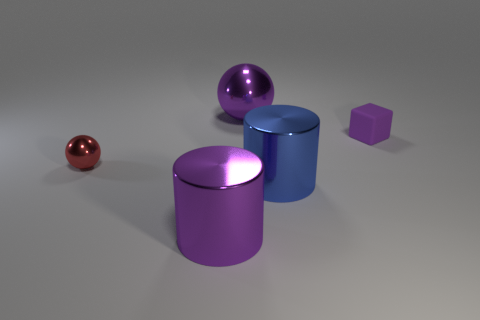How many green things are balls or big metallic things?
Provide a succinct answer. 0. The large metallic sphere has what color?
Offer a terse response. Purple. Are there any other things that are made of the same material as the purple cube?
Provide a short and direct response. No. Are there fewer big purple metallic spheres in front of the big blue cylinder than big blue metal cylinders to the right of the small purple matte object?
Ensure brevity in your answer.  No. There is a metal object that is both behind the blue metallic cylinder and right of the red ball; what is its shape?
Provide a short and direct response. Sphere. What number of big purple metallic things are the same shape as the large blue shiny object?
Ensure brevity in your answer.  1. There is a blue cylinder that is the same material as the big purple ball; what size is it?
Give a very brief answer. Large. What number of blue cylinders are the same size as the purple metallic cylinder?
Keep it short and to the point. 1. There is a ball that is the same color as the tiny cube; what size is it?
Your answer should be very brief. Large. The small object that is behind the object left of the purple cylinder is what color?
Provide a succinct answer. Purple. 